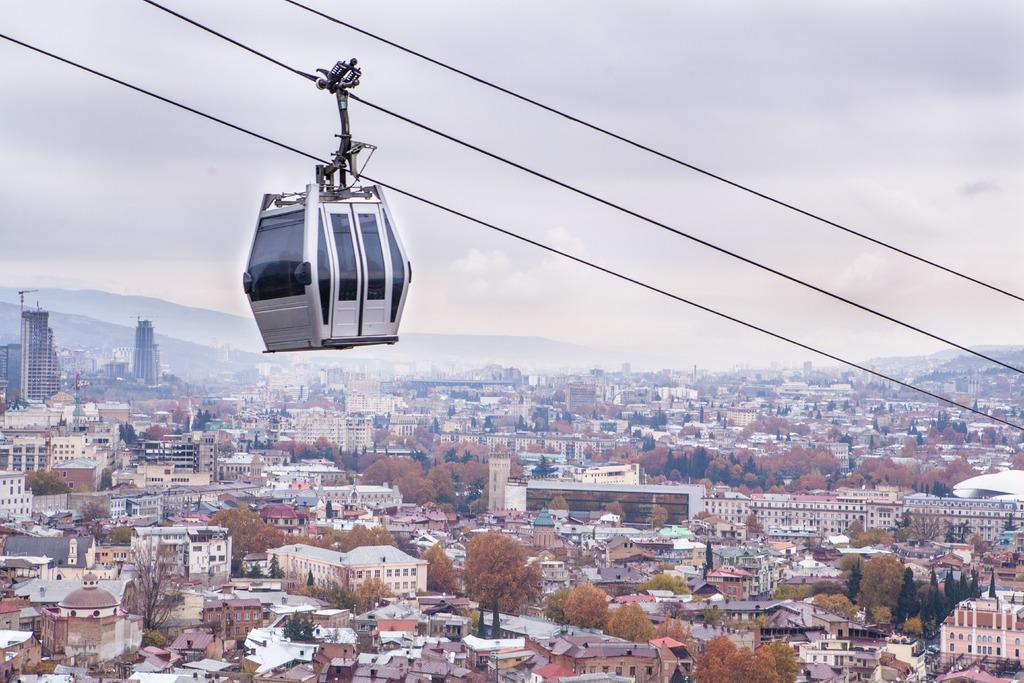How would you summarize this image in a sentence or two? In this image there is the sky, there are buildings, there are trees, there are buildings truncated towards the right of the image, there are buildings truncated towards the left of the image, there are buildings truncated towards the bottom of the image, there are trees truncated towards the bottom of the image, there are mountains truncated towards the left of the image, there is a ropeway, there are wires truncated. 